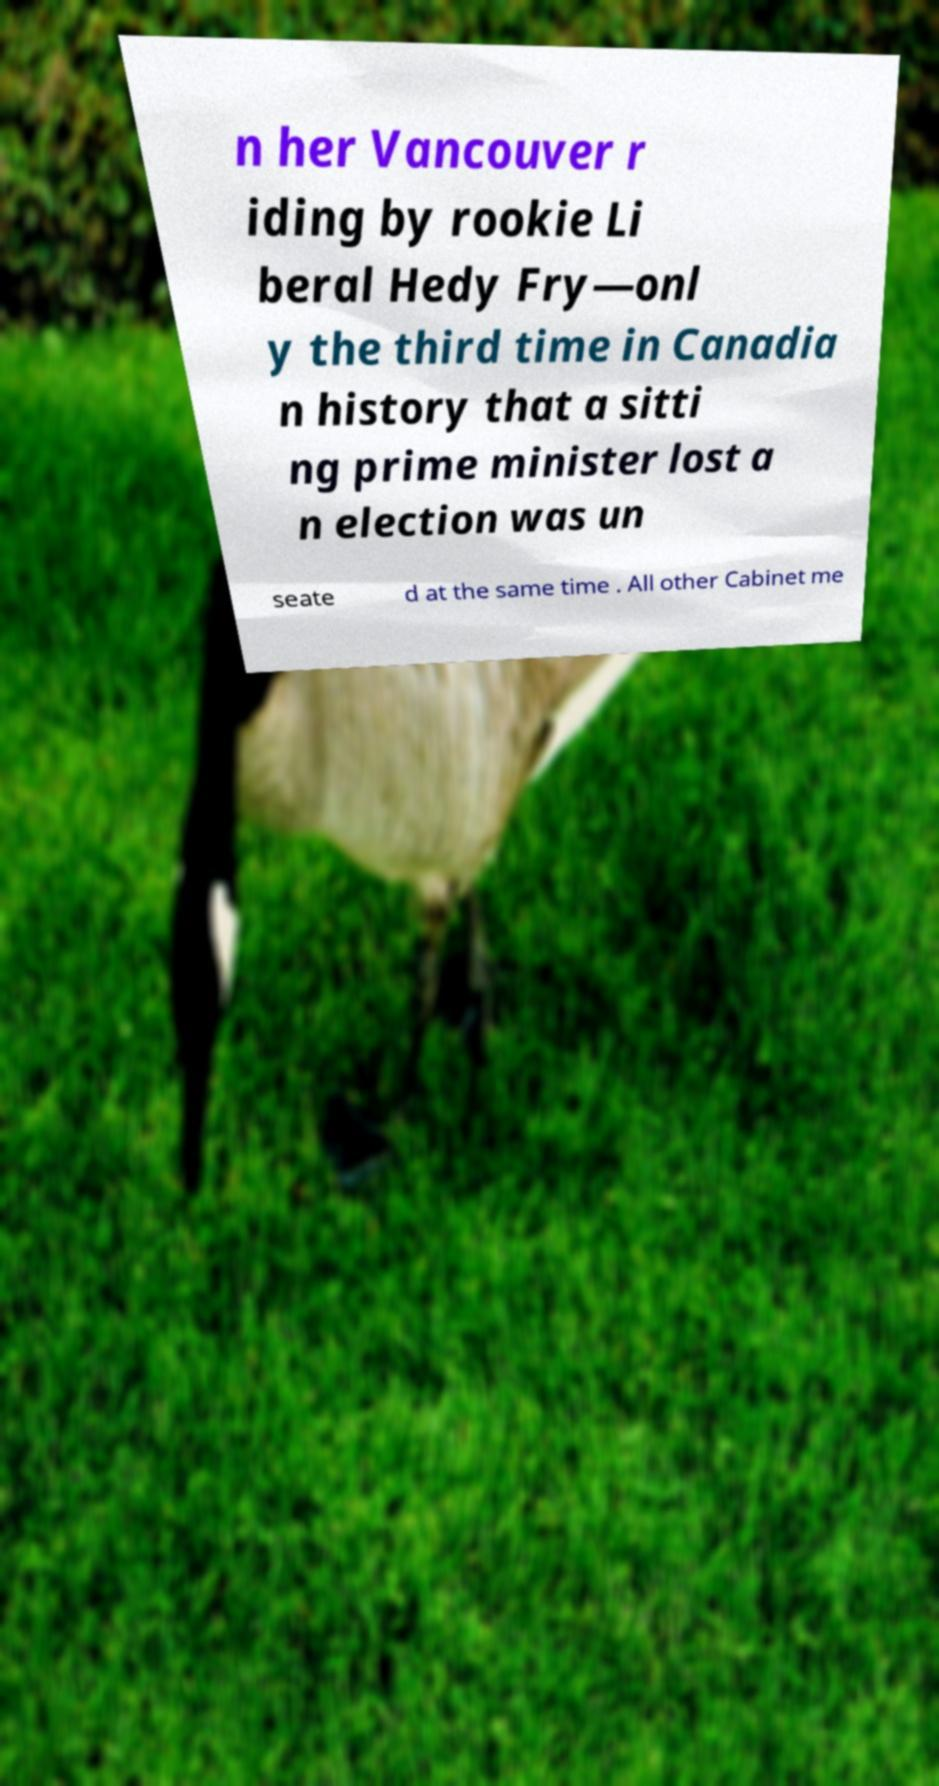Could you assist in decoding the text presented in this image and type it out clearly? n her Vancouver r iding by rookie Li beral Hedy Fry—onl y the third time in Canadia n history that a sitti ng prime minister lost a n election was un seate d at the same time . All other Cabinet me 